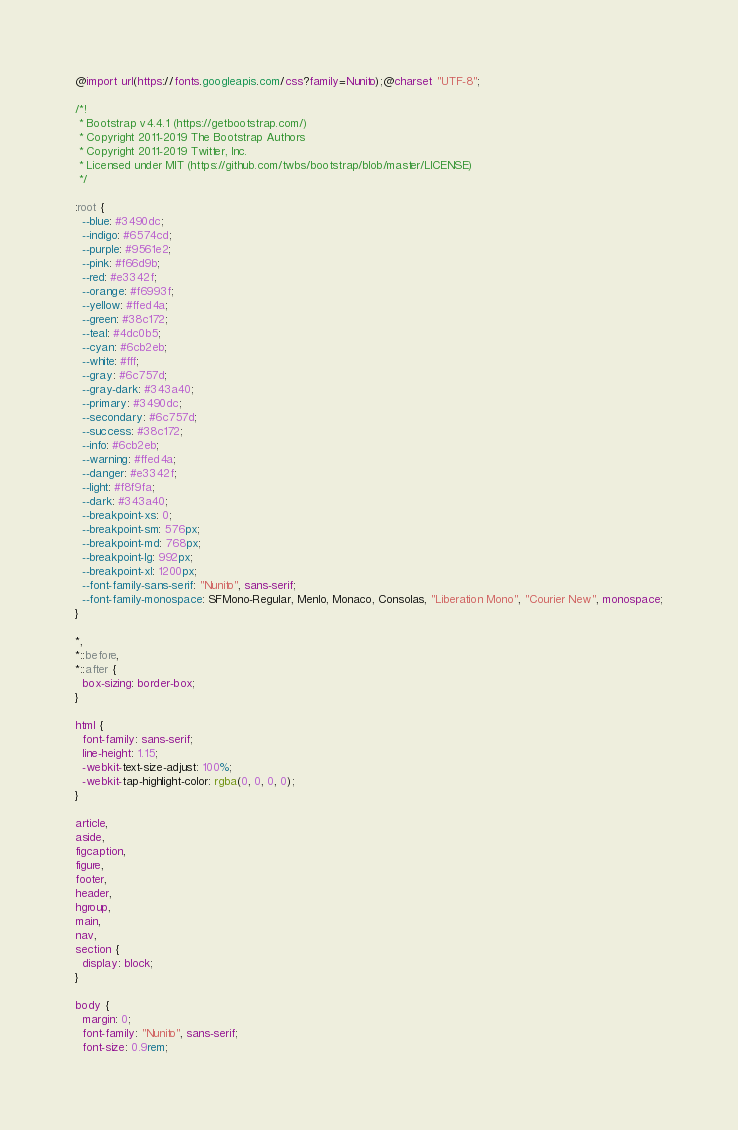Convert code to text. <code><loc_0><loc_0><loc_500><loc_500><_CSS_>@import url(https://fonts.googleapis.com/css?family=Nunito);@charset "UTF-8";

/*!
 * Bootstrap v4.4.1 (https://getbootstrap.com/)
 * Copyright 2011-2019 The Bootstrap Authors
 * Copyright 2011-2019 Twitter, Inc.
 * Licensed under MIT (https://github.com/twbs/bootstrap/blob/master/LICENSE)
 */

:root {
  --blue: #3490dc;
  --indigo: #6574cd;
  --purple: #9561e2;
  --pink: #f66d9b;
  --red: #e3342f;
  --orange: #f6993f;
  --yellow: #ffed4a;
  --green: #38c172;
  --teal: #4dc0b5;
  --cyan: #6cb2eb;
  --white: #fff;
  --gray: #6c757d;
  --gray-dark: #343a40;
  --primary: #3490dc;
  --secondary: #6c757d;
  --success: #38c172;
  --info: #6cb2eb;
  --warning: #ffed4a;
  --danger: #e3342f;
  --light: #f8f9fa;
  --dark: #343a40;
  --breakpoint-xs: 0;
  --breakpoint-sm: 576px;
  --breakpoint-md: 768px;
  --breakpoint-lg: 992px;
  --breakpoint-xl: 1200px;
  --font-family-sans-serif: "Nunito", sans-serif;
  --font-family-monospace: SFMono-Regular, Menlo, Monaco, Consolas, "Liberation Mono", "Courier New", monospace;
}

*,
*::before,
*::after {
  box-sizing: border-box;
}

html {
  font-family: sans-serif;
  line-height: 1.15;
  -webkit-text-size-adjust: 100%;
  -webkit-tap-highlight-color: rgba(0, 0, 0, 0);
}

article,
aside,
figcaption,
figure,
footer,
header,
hgroup,
main,
nav,
section {
  display: block;
}

body {
  margin: 0;
  font-family: "Nunito", sans-serif;
  font-size: 0.9rem;</code> 